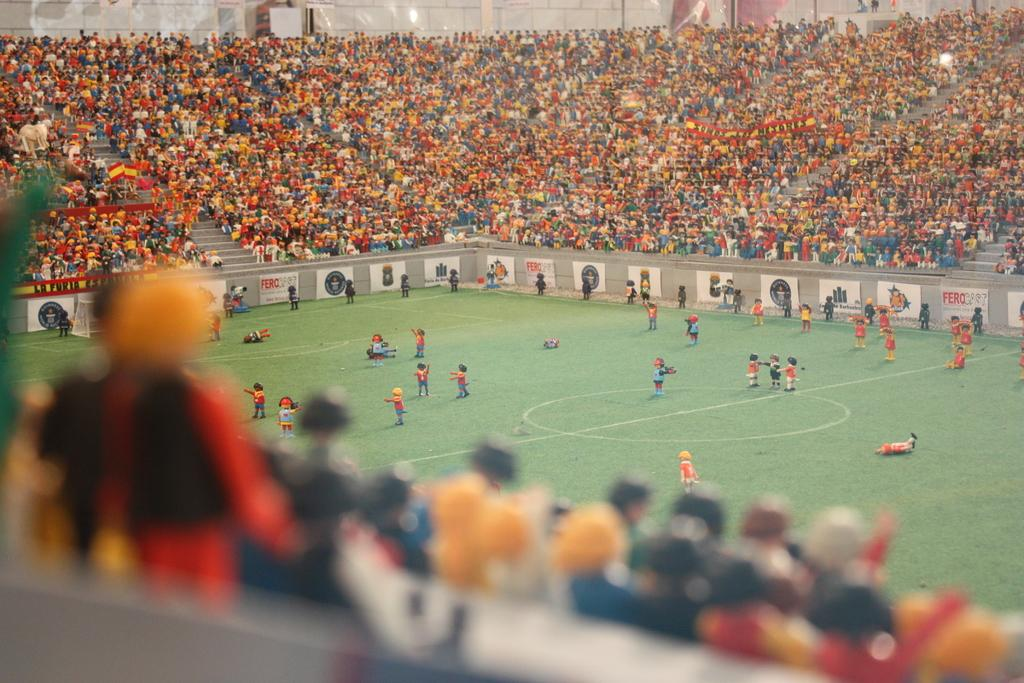What is happening on the ground in the image? There are people on the ground in the image. What can be seen in the background of the image? There is a crowd in the background of the image. What type of signage is visible in the image? There are banners and flags present in the image. What else can be seen in the image besides people and signage? There are boards in the image. How many thumbs are visible in the image? There is no specific mention of thumbs in the image, so it is not possible to determine the number of thumbs visible. 